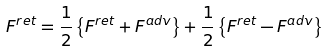Convert formula to latex. <formula><loc_0><loc_0><loc_500><loc_500>F ^ { r e t } = \frac { 1 } { 2 } \left \{ F ^ { r e t } + F ^ { a d v } \right \} + \frac { 1 } { 2 } \left \{ F ^ { r e t } - F ^ { a d v } \right \}</formula> 